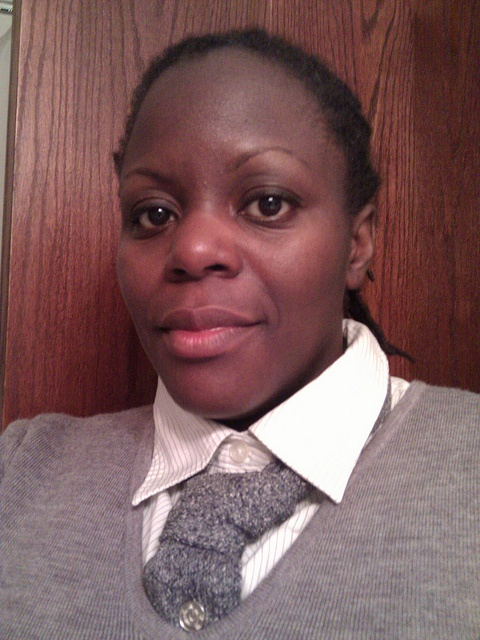Describe the objects in this image and their specific colors. I can see people in gray, brown, and maroon tones and tie in gray tones in this image. 